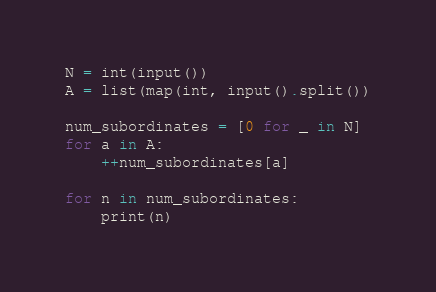<code> <loc_0><loc_0><loc_500><loc_500><_Python_>N = int(input())
A = list(map(int, input().split())

num_subordinates = [0 for _ in N]
for a in A:
	++num_subordinates[a]

for n in num_subordinates:
	print(n)</code> 